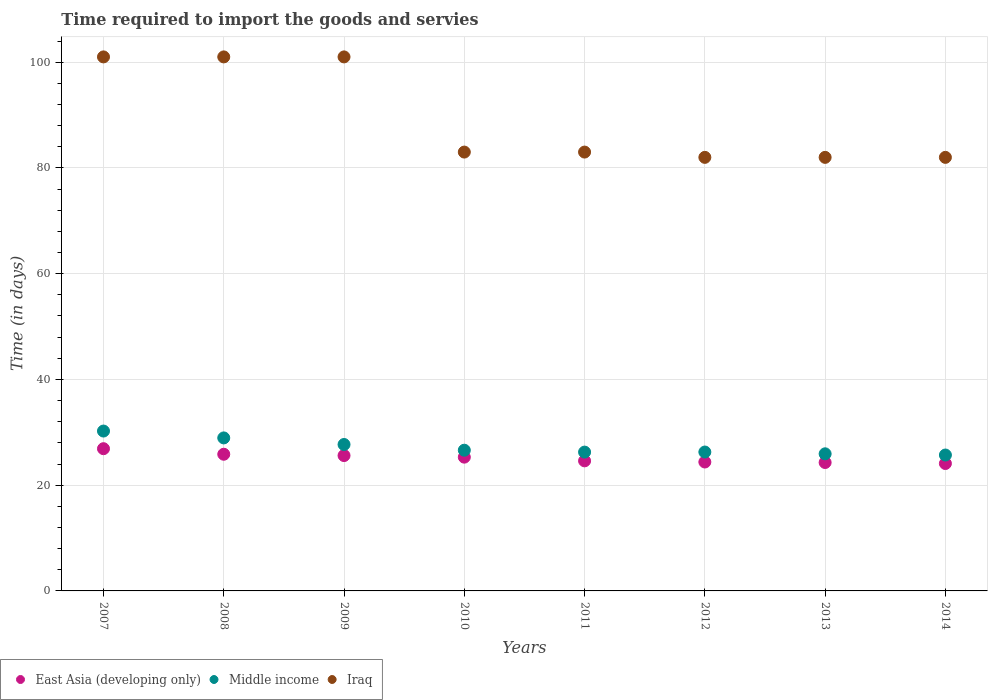How many different coloured dotlines are there?
Offer a terse response. 3. What is the number of days required to import the goods and services in East Asia (developing only) in 2010?
Offer a terse response. 25.3. Across all years, what is the maximum number of days required to import the goods and services in Iraq?
Keep it short and to the point. 101. Across all years, what is the minimum number of days required to import the goods and services in Middle income?
Give a very brief answer. 25.7. In which year was the number of days required to import the goods and services in Middle income minimum?
Ensure brevity in your answer.  2014. What is the total number of days required to import the goods and services in Iraq in the graph?
Make the answer very short. 715. What is the difference between the number of days required to import the goods and services in Middle income in 2008 and that in 2014?
Your answer should be very brief. 3.24. What is the difference between the number of days required to import the goods and services in Iraq in 2013 and the number of days required to import the goods and services in Middle income in 2008?
Offer a terse response. 53.06. What is the average number of days required to import the goods and services in Middle income per year?
Your response must be concise. 27.21. In the year 2013, what is the difference between the number of days required to import the goods and services in Iraq and number of days required to import the goods and services in Middle income?
Keep it short and to the point. 56.07. What is the ratio of the number of days required to import the goods and services in East Asia (developing only) in 2010 to that in 2014?
Your answer should be compact. 1.05. Is the number of days required to import the goods and services in Middle income in 2010 less than that in 2013?
Make the answer very short. No. What is the difference between the highest and the second highest number of days required to import the goods and services in Middle income?
Ensure brevity in your answer.  1.3. What is the difference between the highest and the lowest number of days required to import the goods and services in Iraq?
Your response must be concise. 19. In how many years, is the number of days required to import the goods and services in Middle income greater than the average number of days required to import the goods and services in Middle income taken over all years?
Your response must be concise. 3. Is the sum of the number of days required to import the goods and services in Iraq in 2007 and 2013 greater than the maximum number of days required to import the goods and services in East Asia (developing only) across all years?
Your answer should be very brief. Yes. Is it the case that in every year, the sum of the number of days required to import the goods and services in East Asia (developing only) and number of days required to import the goods and services in Middle income  is greater than the number of days required to import the goods and services in Iraq?
Provide a succinct answer. No. How many years are there in the graph?
Provide a succinct answer. 8. What is the difference between two consecutive major ticks on the Y-axis?
Offer a very short reply. 20. Where does the legend appear in the graph?
Make the answer very short. Bottom left. What is the title of the graph?
Give a very brief answer. Time required to import the goods and servies. Does "Mauritius" appear as one of the legend labels in the graph?
Your answer should be compact. No. What is the label or title of the X-axis?
Your answer should be very brief. Years. What is the label or title of the Y-axis?
Offer a terse response. Time (in days). What is the Time (in days) of East Asia (developing only) in 2007?
Offer a terse response. 26.9. What is the Time (in days) of Middle income in 2007?
Your answer should be compact. 30.24. What is the Time (in days) in Iraq in 2007?
Ensure brevity in your answer.  101. What is the Time (in days) of East Asia (developing only) in 2008?
Your answer should be compact. 25.85. What is the Time (in days) of Middle income in 2008?
Your answer should be very brief. 28.94. What is the Time (in days) of Iraq in 2008?
Keep it short and to the point. 101. What is the Time (in days) of East Asia (developing only) in 2009?
Give a very brief answer. 25.6. What is the Time (in days) of Middle income in 2009?
Offer a terse response. 27.69. What is the Time (in days) of Iraq in 2009?
Offer a terse response. 101. What is the Time (in days) of East Asia (developing only) in 2010?
Provide a succinct answer. 25.3. What is the Time (in days) in Middle income in 2010?
Your answer should be very brief. 26.61. What is the Time (in days) in Iraq in 2010?
Your response must be concise. 83. What is the Time (in days) of East Asia (developing only) in 2011?
Ensure brevity in your answer.  24.6. What is the Time (in days) of Middle income in 2011?
Your response must be concise. 26.26. What is the Time (in days) in East Asia (developing only) in 2012?
Give a very brief answer. 24.38. What is the Time (in days) of Middle income in 2012?
Your response must be concise. 26.27. What is the Time (in days) in Iraq in 2012?
Provide a short and direct response. 82. What is the Time (in days) in East Asia (developing only) in 2013?
Your answer should be compact. 24.29. What is the Time (in days) in Middle income in 2013?
Your answer should be very brief. 25.93. What is the Time (in days) of East Asia (developing only) in 2014?
Make the answer very short. 24.1. What is the Time (in days) of Middle income in 2014?
Keep it short and to the point. 25.7. Across all years, what is the maximum Time (in days) in East Asia (developing only)?
Your answer should be compact. 26.9. Across all years, what is the maximum Time (in days) in Middle income?
Ensure brevity in your answer.  30.24. Across all years, what is the maximum Time (in days) of Iraq?
Keep it short and to the point. 101. Across all years, what is the minimum Time (in days) of East Asia (developing only)?
Provide a short and direct response. 24.1. Across all years, what is the minimum Time (in days) in Middle income?
Your answer should be compact. 25.7. Across all years, what is the minimum Time (in days) in Iraq?
Offer a terse response. 82. What is the total Time (in days) in East Asia (developing only) in the graph?
Give a very brief answer. 201.01. What is the total Time (in days) in Middle income in the graph?
Offer a terse response. 217.64. What is the total Time (in days) in Iraq in the graph?
Provide a short and direct response. 715. What is the difference between the Time (in days) of Middle income in 2007 and that in 2008?
Provide a short and direct response. 1.3. What is the difference between the Time (in days) in Middle income in 2007 and that in 2009?
Make the answer very short. 2.54. What is the difference between the Time (in days) of East Asia (developing only) in 2007 and that in 2010?
Give a very brief answer. 1.6. What is the difference between the Time (in days) of Middle income in 2007 and that in 2010?
Keep it short and to the point. 3.62. What is the difference between the Time (in days) in Middle income in 2007 and that in 2011?
Ensure brevity in your answer.  3.98. What is the difference between the Time (in days) of East Asia (developing only) in 2007 and that in 2012?
Your answer should be very brief. 2.52. What is the difference between the Time (in days) of Middle income in 2007 and that in 2012?
Give a very brief answer. 3.97. What is the difference between the Time (in days) in East Asia (developing only) in 2007 and that in 2013?
Your answer should be very brief. 2.61. What is the difference between the Time (in days) in Middle income in 2007 and that in 2013?
Offer a terse response. 4.31. What is the difference between the Time (in days) in East Asia (developing only) in 2007 and that in 2014?
Provide a short and direct response. 2.8. What is the difference between the Time (in days) of Middle income in 2007 and that in 2014?
Your response must be concise. 4.54. What is the difference between the Time (in days) in Iraq in 2007 and that in 2014?
Offer a terse response. 19. What is the difference between the Time (in days) of East Asia (developing only) in 2008 and that in 2009?
Provide a short and direct response. 0.25. What is the difference between the Time (in days) in Middle income in 2008 and that in 2009?
Offer a very short reply. 1.24. What is the difference between the Time (in days) of Iraq in 2008 and that in 2009?
Keep it short and to the point. 0. What is the difference between the Time (in days) of East Asia (developing only) in 2008 and that in 2010?
Your response must be concise. 0.55. What is the difference between the Time (in days) of Middle income in 2008 and that in 2010?
Give a very brief answer. 2.33. What is the difference between the Time (in days) of Middle income in 2008 and that in 2011?
Your answer should be compact. 2.68. What is the difference between the Time (in days) of East Asia (developing only) in 2008 and that in 2012?
Provide a short and direct response. 1.47. What is the difference between the Time (in days) of Middle income in 2008 and that in 2012?
Offer a very short reply. 2.67. What is the difference between the Time (in days) in East Asia (developing only) in 2008 and that in 2013?
Give a very brief answer. 1.56. What is the difference between the Time (in days) in Middle income in 2008 and that in 2013?
Ensure brevity in your answer.  3.01. What is the difference between the Time (in days) in East Asia (developing only) in 2008 and that in 2014?
Keep it short and to the point. 1.75. What is the difference between the Time (in days) of Middle income in 2008 and that in 2014?
Keep it short and to the point. 3.24. What is the difference between the Time (in days) in Iraq in 2008 and that in 2014?
Ensure brevity in your answer.  19. What is the difference between the Time (in days) in East Asia (developing only) in 2009 and that in 2010?
Keep it short and to the point. 0.3. What is the difference between the Time (in days) of Middle income in 2009 and that in 2010?
Keep it short and to the point. 1.08. What is the difference between the Time (in days) in Iraq in 2009 and that in 2010?
Ensure brevity in your answer.  18. What is the difference between the Time (in days) of Middle income in 2009 and that in 2011?
Your answer should be compact. 1.44. What is the difference between the Time (in days) of Iraq in 2009 and that in 2011?
Offer a very short reply. 18. What is the difference between the Time (in days) in East Asia (developing only) in 2009 and that in 2012?
Provide a succinct answer. 1.22. What is the difference between the Time (in days) in Middle income in 2009 and that in 2012?
Your answer should be very brief. 1.42. What is the difference between the Time (in days) of Iraq in 2009 and that in 2012?
Ensure brevity in your answer.  19. What is the difference between the Time (in days) in East Asia (developing only) in 2009 and that in 2013?
Make the answer very short. 1.31. What is the difference between the Time (in days) in Middle income in 2009 and that in 2013?
Offer a very short reply. 1.76. What is the difference between the Time (in days) in East Asia (developing only) in 2009 and that in 2014?
Offer a terse response. 1.5. What is the difference between the Time (in days) of Middle income in 2009 and that in 2014?
Keep it short and to the point. 1.99. What is the difference between the Time (in days) in Middle income in 2010 and that in 2011?
Give a very brief answer. 0.36. What is the difference between the Time (in days) in Iraq in 2010 and that in 2011?
Make the answer very short. 0. What is the difference between the Time (in days) of East Asia (developing only) in 2010 and that in 2012?
Your answer should be very brief. 0.92. What is the difference between the Time (in days) in Middle income in 2010 and that in 2012?
Keep it short and to the point. 0.34. What is the difference between the Time (in days) in East Asia (developing only) in 2010 and that in 2013?
Make the answer very short. 1.01. What is the difference between the Time (in days) of Middle income in 2010 and that in 2013?
Provide a succinct answer. 0.68. What is the difference between the Time (in days) of Iraq in 2010 and that in 2013?
Offer a very short reply. 1. What is the difference between the Time (in days) in East Asia (developing only) in 2010 and that in 2014?
Offer a very short reply. 1.2. What is the difference between the Time (in days) in Middle income in 2010 and that in 2014?
Make the answer very short. 0.91. What is the difference between the Time (in days) of Iraq in 2010 and that in 2014?
Offer a very short reply. 1. What is the difference between the Time (in days) in East Asia (developing only) in 2011 and that in 2012?
Offer a very short reply. 0.22. What is the difference between the Time (in days) of Middle income in 2011 and that in 2012?
Give a very brief answer. -0.01. What is the difference between the Time (in days) of East Asia (developing only) in 2011 and that in 2013?
Provide a succinct answer. 0.31. What is the difference between the Time (in days) in Middle income in 2011 and that in 2013?
Your response must be concise. 0.32. What is the difference between the Time (in days) in East Asia (developing only) in 2011 and that in 2014?
Your answer should be compact. 0.5. What is the difference between the Time (in days) of Middle income in 2011 and that in 2014?
Ensure brevity in your answer.  0.55. What is the difference between the Time (in days) of Iraq in 2011 and that in 2014?
Provide a short and direct response. 1. What is the difference between the Time (in days) in East Asia (developing only) in 2012 and that in 2013?
Your answer should be compact. 0.1. What is the difference between the Time (in days) in Middle income in 2012 and that in 2013?
Your answer should be compact. 0.34. What is the difference between the Time (in days) in East Asia (developing only) in 2012 and that in 2014?
Your answer should be compact. 0.29. What is the difference between the Time (in days) of Middle income in 2012 and that in 2014?
Your answer should be compact. 0.57. What is the difference between the Time (in days) of East Asia (developing only) in 2013 and that in 2014?
Offer a very short reply. 0.19. What is the difference between the Time (in days) of Middle income in 2013 and that in 2014?
Your answer should be very brief. 0.23. What is the difference between the Time (in days) in East Asia (developing only) in 2007 and the Time (in days) in Middle income in 2008?
Offer a terse response. -2.04. What is the difference between the Time (in days) in East Asia (developing only) in 2007 and the Time (in days) in Iraq in 2008?
Offer a terse response. -74.1. What is the difference between the Time (in days) in Middle income in 2007 and the Time (in days) in Iraq in 2008?
Give a very brief answer. -70.76. What is the difference between the Time (in days) in East Asia (developing only) in 2007 and the Time (in days) in Middle income in 2009?
Ensure brevity in your answer.  -0.79. What is the difference between the Time (in days) of East Asia (developing only) in 2007 and the Time (in days) of Iraq in 2009?
Provide a succinct answer. -74.1. What is the difference between the Time (in days) in Middle income in 2007 and the Time (in days) in Iraq in 2009?
Offer a terse response. -70.76. What is the difference between the Time (in days) of East Asia (developing only) in 2007 and the Time (in days) of Middle income in 2010?
Keep it short and to the point. 0.29. What is the difference between the Time (in days) in East Asia (developing only) in 2007 and the Time (in days) in Iraq in 2010?
Offer a terse response. -56.1. What is the difference between the Time (in days) in Middle income in 2007 and the Time (in days) in Iraq in 2010?
Your answer should be compact. -52.76. What is the difference between the Time (in days) in East Asia (developing only) in 2007 and the Time (in days) in Middle income in 2011?
Your answer should be very brief. 0.64. What is the difference between the Time (in days) of East Asia (developing only) in 2007 and the Time (in days) of Iraq in 2011?
Ensure brevity in your answer.  -56.1. What is the difference between the Time (in days) of Middle income in 2007 and the Time (in days) of Iraq in 2011?
Your response must be concise. -52.76. What is the difference between the Time (in days) of East Asia (developing only) in 2007 and the Time (in days) of Middle income in 2012?
Your answer should be very brief. 0.63. What is the difference between the Time (in days) in East Asia (developing only) in 2007 and the Time (in days) in Iraq in 2012?
Your answer should be very brief. -55.1. What is the difference between the Time (in days) in Middle income in 2007 and the Time (in days) in Iraq in 2012?
Offer a very short reply. -51.76. What is the difference between the Time (in days) of East Asia (developing only) in 2007 and the Time (in days) of Iraq in 2013?
Keep it short and to the point. -55.1. What is the difference between the Time (in days) of Middle income in 2007 and the Time (in days) of Iraq in 2013?
Keep it short and to the point. -51.76. What is the difference between the Time (in days) of East Asia (developing only) in 2007 and the Time (in days) of Middle income in 2014?
Offer a terse response. 1.2. What is the difference between the Time (in days) of East Asia (developing only) in 2007 and the Time (in days) of Iraq in 2014?
Make the answer very short. -55.1. What is the difference between the Time (in days) in Middle income in 2007 and the Time (in days) in Iraq in 2014?
Your answer should be compact. -51.76. What is the difference between the Time (in days) of East Asia (developing only) in 2008 and the Time (in days) of Middle income in 2009?
Give a very brief answer. -1.84. What is the difference between the Time (in days) in East Asia (developing only) in 2008 and the Time (in days) in Iraq in 2009?
Provide a short and direct response. -75.15. What is the difference between the Time (in days) in Middle income in 2008 and the Time (in days) in Iraq in 2009?
Give a very brief answer. -72.06. What is the difference between the Time (in days) of East Asia (developing only) in 2008 and the Time (in days) of Middle income in 2010?
Make the answer very short. -0.76. What is the difference between the Time (in days) of East Asia (developing only) in 2008 and the Time (in days) of Iraq in 2010?
Offer a terse response. -57.15. What is the difference between the Time (in days) in Middle income in 2008 and the Time (in days) in Iraq in 2010?
Provide a short and direct response. -54.06. What is the difference between the Time (in days) in East Asia (developing only) in 2008 and the Time (in days) in Middle income in 2011?
Provide a succinct answer. -0.41. What is the difference between the Time (in days) in East Asia (developing only) in 2008 and the Time (in days) in Iraq in 2011?
Provide a short and direct response. -57.15. What is the difference between the Time (in days) of Middle income in 2008 and the Time (in days) of Iraq in 2011?
Give a very brief answer. -54.06. What is the difference between the Time (in days) of East Asia (developing only) in 2008 and the Time (in days) of Middle income in 2012?
Give a very brief answer. -0.42. What is the difference between the Time (in days) in East Asia (developing only) in 2008 and the Time (in days) in Iraq in 2012?
Keep it short and to the point. -56.15. What is the difference between the Time (in days) of Middle income in 2008 and the Time (in days) of Iraq in 2012?
Your response must be concise. -53.06. What is the difference between the Time (in days) in East Asia (developing only) in 2008 and the Time (in days) in Middle income in 2013?
Give a very brief answer. -0.08. What is the difference between the Time (in days) of East Asia (developing only) in 2008 and the Time (in days) of Iraq in 2013?
Offer a very short reply. -56.15. What is the difference between the Time (in days) of Middle income in 2008 and the Time (in days) of Iraq in 2013?
Provide a succinct answer. -53.06. What is the difference between the Time (in days) in East Asia (developing only) in 2008 and the Time (in days) in Middle income in 2014?
Offer a terse response. 0.15. What is the difference between the Time (in days) in East Asia (developing only) in 2008 and the Time (in days) in Iraq in 2014?
Keep it short and to the point. -56.15. What is the difference between the Time (in days) in Middle income in 2008 and the Time (in days) in Iraq in 2014?
Keep it short and to the point. -53.06. What is the difference between the Time (in days) of East Asia (developing only) in 2009 and the Time (in days) of Middle income in 2010?
Offer a terse response. -1.01. What is the difference between the Time (in days) in East Asia (developing only) in 2009 and the Time (in days) in Iraq in 2010?
Provide a short and direct response. -57.4. What is the difference between the Time (in days) in Middle income in 2009 and the Time (in days) in Iraq in 2010?
Offer a terse response. -55.31. What is the difference between the Time (in days) of East Asia (developing only) in 2009 and the Time (in days) of Middle income in 2011?
Provide a short and direct response. -0.66. What is the difference between the Time (in days) of East Asia (developing only) in 2009 and the Time (in days) of Iraq in 2011?
Give a very brief answer. -57.4. What is the difference between the Time (in days) in Middle income in 2009 and the Time (in days) in Iraq in 2011?
Your answer should be very brief. -55.31. What is the difference between the Time (in days) of East Asia (developing only) in 2009 and the Time (in days) of Middle income in 2012?
Your answer should be compact. -0.67. What is the difference between the Time (in days) of East Asia (developing only) in 2009 and the Time (in days) of Iraq in 2012?
Ensure brevity in your answer.  -56.4. What is the difference between the Time (in days) in Middle income in 2009 and the Time (in days) in Iraq in 2012?
Your response must be concise. -54.31. What is the difference between the Time (in days) of East Asia (developing only) in 2009 and the Time (in days) of Middle income in 2013?
Your response must be concise. -0.33. What is the difference between the Time (in days) of East Asia (developing only) in 2009 and the Time (in days) of Iraq in 2013?
Your answer should be compact. -56.4. What is the difference between the Time (in days) in Middle income in 2009 and the Time (in days) in Iraq in 2013?
Your answer should be compact. -54.31. What is the difference between the Time (in days) of East Asia (developing only) in 2009 and the Time (in days) of Middle income in 2014?
Offer a terse response. -0.1. What is the difference between the Time (in days) in East Asia (developing only) in 2009 and the Time (in days) in Iraq in 2014?
Keep it short and to the point. -56.4. What is the difference between the Time (in days) of Middle income in 2009 and the Time (in days) of Iraq in 2014?
Provide a succinct answer. -54.31. What is the difference between the Time (in days) in East Asia (developing only) in 2010 and the Time (in days) in Middle income in 2011?
Your response must be concise. -0.96. What is the difference between the Time (in days) of East Asia (developing only) in 2010 and the Time (in days) of Iraq in 2011?
Your answer should be very brief. -57.7. What is the difference between the Time (in days) in Middle income in 2010 and the Time (in days) in Iraq in 2011?
Make the answer very short. -56.39. What is the difference between the Time (in days) of East Asia (developing only) in 2010 and the Time (in days) of Middle income in 2012?
Make the answer very short. -0.97. What is the difference between the Time (in days) of East Asia (developing only) in 2010 and the Time (in days) of Iraq in 2012?
Make the answer very short. -56.7. What is the difference between the Time (in days) of Middle income in 2010 and the Time (in days) of Iraq in 2012?
Ensure brevity in your answer.  -55.39. What is the difference between the Time (in days) of East Asia (developing only) in 2010 and the Time (in days) of Middle income in 2013?
Provide a short and direct response. -0.63. What is the difference between the Time (in days) of East Asia (developing only) in 2010 and the Time (in days) of Iraq in 2013?
Give a very brief answer. -56.7. What is the difference between the Time (in days) of Middle income in 2010 and the Time (in days) of Iraq in 2013?
Keep it short and to the point. -55.39. What is the difference between the Time (in days) in East Asia (developing only) in 2010 and the Time (in days) in Middle income in 2014?
Your response must be concise. -0.4. What is the difference between the Time (in days) of East Asia (developing only) in 2010 and the Time (in days) of Iraq in 2014?
Keep it short and to the point. -56.7. What is the difference between the Time (in days) of Middle income in 2010 and the Time (in days) of Iraq in 2014?
Your answer should be compact. -55.39. What is the difference between the Time (in days) in East Asia (developing only) in 2011 and the Time (in days) in Middle income in 2012?
Make the answer very short. -1.67. What is the difference between the Time (in days) of East Asia (developing only) in 2011 and the Time (in days) of Iraq in 2012?
Offer a terse response. -57.4. What is the difference between the Time (in days) in Middle income in 2011 and the Time (in days) in Iraq in 2012?
Your answer should be compact. -55.74. What is the difference between the Time (in days) of East Asia (developing only) in 2011 and the Time (in days) of Middle income in 2013?
Provide a short and direct response. -1.33. What is the difference between the Time (in days) in East Asia (developing only) in 2011 and the Time (in days) in Iraq in 2013?
Provide a succinct answer. -57.4. What is the difference between the Time (in days) in Middle income in 2011 and the Time (in days) in Iraq in 2013?
Your answer should be very brief. -55.74. What is the difference between the Time (in days) of East Asia (developing only) in 2011 and the Time (in days) of Middle income in 2014?
Make the answer very short. -1.1. What is the difference between the Time (in days) in East Asia (developing only) in 2011 and the Time (in days) in Iraq in 2014?
Provide a short and direct response. -57.4. What is the difference between the Time (in days) of Middle income in 2011 and the Time (in days) of Iraq in 2014?
Give a very brief answer. -55.74. What is the difference between the Time (in days) in East Asia (developing only) in 2012 and the Time (in days) in Middle income in 2013?
Give a very brief answer. -1.55. What is the difference between the Time (in days) in East Asia (developing only) in 2012 and the Time (in days) in Iraq in 2013?
Your response must be concise. -57.62. What is the difference between the Time (in days) of Middle income in 2012 and the Time (in days) of Iraq in 2013?
Your answer should be very brief. -55.73. What is the difference between the Time (in days) of East Asia (developing only) in 2012 and the Time (in days) of Middle income in 2014?
Provide a succinct answer. -1.32. What is the difference between the Time (in days) of East Asia (developing only) in 2012 and the Time (in days) of Iraq in 2014?
Your response must be concise. -57.62. What is the difference between the Time (in days) in Middle income in 2012 and the Time (in days) in Iraq in 2014?
Your answer should be very brief. -55.73. What is the difference between the Time (in days) of East Asia (developing only) in 2013 and the Time (in days) of Middle income in 2014?
Ensure brevity in your answer.  -1.42. What is the difference between the Time (in days) in East Asia (developing only) in 2013 and the Time (in days) in Iraq in 2014?
Your response must be concise. -57.71. What is the difference between the Time (in days) in Middle income in 2013 and the Time (in days) in Iraq in 2014?
Give a very brief answer. -56.07. What is the average Time (in days) in East Asia (developing only) per year?
Offer a very short reply. 25.13. What is the average Time (in days) in Middle income per year?
Provide a short and direct response. 27.21. What is the average Time (in days) of Iraq per year?
Your response must be concise. 89.38. In the year 2007, what is the difference between the Time (in days) in East Asia (developing only) and Time (in days) in Middle income?
Offer a terse response. -3.34. In the year 2007, what is the difference between the Time (in days) in East Asia (developing only) and Time (in days) in Iraq?
Offer a terse response. -74.1. In the year 2007, what is the difference between the Time (in days) in Middle income and Time (in days) in Iraq?
Offer a very short reply. -70.76. In the year 2008, what is the difference between the Time (in days) of East Asia (developing only) and Time (in days) of Middle income?
Your answer should be compact. -3.09. In the year 2008, what is the difference between the Time (in days) of East Asia (developing only) and Time (in days) of Iraq?
Provide a succinct answer. -75.15. In the year 2008, what is the difference between the Time (in days) of Middle income and Time (in days) of Iraq?
Offer a very short reply. -72.06. In the year 2009, what is the difference between the Time (in days) in East Asia (developing only) and Time (in days) in Middle income?
Your answer should be very brief. -2.09. In the year 2009, what is the difference between the Time (in days) of East Asia (developing only) and Time (in days) of Iraq?
Make the answer very short. -75.4. In the year 2009, what is the difference between the Time (in days) of Middle income and Time (in days) of Iraq?
Provide a short and direct response. -73.31. In the year 2010, what is the difference between the Time (in days) of East Asia (developing only) and Time (in days) of Middle income?
Your response must be concise. -1.31. In the year 2010, what is the difference between the Time (in days) in East Asia (developing only) and Time (in days) in Iraq?
Your response must be concise. -57.7. In the year 2010, what is the difference between the Time (in days) in Middle income and Time (in days) in Iraq?
Offer a very short reply. -56.39. In the year 2011, what is the difference between the Time (in days) in East Asia (developing only) and Time (in days) in Middle income?
Your answer should be compact. -1.66. In the year 2011, what is the difference between the Time (in days) in East Asia (developing only) and Time (in days) in Iraq?
Your answer should be very brief. -58.4. In the year 2011, what is the difference between the Time (in days) of Middle income and Time (in days) of Iraq?
Make the answer very short. -56.74. In the year 2012, what is the difference between the Time (in days) of East Asia (developing only) and Time (in days) of Middle income?
Ensure brevity in your answer.  -1.89. In the year 2012, what is the difference between the Time (in days) of East Asia (developing only) and Time (in days) of Iraq?
Offer a terse response. -57.62. In the year 2012, what is the difference between the Time (in days) of Middle income and Time (in days) of Iraq?
Offer a terse response. -55.73. In the year 2013, what is the difference between the Time (in days) of East Asia (developing only) and Time (in days) of Middle income?
Offer a very short reply. -1.65. In the year 2013, what is the difference between the Time (in days) of East Asia (developing only) and Time (in days) of Iraq?
Keep it short and to the point. -57.71. In the year 2013, what is the difference between the Time (in days) of Middle income and Time (in days) of Iraq?
Ensure brevity in your answer.  -56.07. In the year 2014, what is the difference between the Time (in days) of East Asia (developing only) and Time (in days) of Middle income?
Provide a short and direct response. -1.61. In the year 2014, what is the difference between the Time (in days) of East Asia (developing only) and Time (in days) of Iraq?
Ensure brevity in your answer.  -57.9. In the year 2014, what is the difference between the Time (in days) in Middle income and Time (in days) in Iraq?
Ensure brevity in your answer.  -56.3. What is the ratio of the Time (in days) of East Asia (developing only) in 2007 to that in 2008?
Your answer should be compact. 1.04. What is the ratio of the Time (in days) in Middle income in 2007 to that in 2008?
Your response must be concise. 1.04. What is the ratio of the Time (in days) of Iraq in 2007 to that in 2008?
Your answer should be very brief. 1. What is the ratio of the Time (in days) in East Asia (developing only) in 2007 to that in 2009?
Provide a succinct answer. 1.05. What is the ratio of the Time (in days) in Middle income in 2007 to that in 2009?
Your response must be concise. 1.09. What is the ratio of the Time (in days) in East Asia (developing only) in 2007 to that in 2010?
Offer a very short reply. 1.06. What is the ratio of the Time (in days) of Middle income in 2007 to that in 2010?
Offer a terse response. 1.14. What is the ratio of the Time (in days) in Iraq in 2007 to that in 2010?
Keep it short and to the point. 1.22. What is the ratio of the Time (in days) of East Asia (developing only) in 2007 to that in 2011?
Your response must be concise. 1.09. What is the ratio of the Time (in days) in Middle income in 2007 to that in 2011?
Make the answer very short. 1.15. What is the ratio of the Time (in days) in Iraq in 2007 to that in 2011?
Keep it short and to the point. 1.22. What is the ratio of the Time (in days) in East Asia (developing only) in 2007 to that in 2012?
Offer a very short reply. 1.1. What is the ratio of the Time (in days) in Middle income in 2007 to that in 2012?
Give a very brief answer. 1.15. What is the ratio of the Time (in days) in Iraq in 2007 to that in 2012?
Ensure brevity in your answer.  1.23. What is the ratio of the Time (in days) of East Asia (developing only) in 2007 to that in 2013?
Provide a short and direct response. 1.11. What is the ratio of the Time (in days) in Middle income in 2007 to that in 2013?
Ensure brevity in your answer.  1.17. What is the ratio of the Time (in days) in Iraq in 2007 to that in 2013?
Your answer should be very brief. 1.23. What is the ratio of the Time (in days) in East Asia (developing only) in 2007 to that in 2014?
Your response must be concise. 1.12. What is the ratio of the Time (in days) of Middle income in 2007 to that in 2014?
Your response must be concise. 1.18. What is the ratio of the Time (in days) of Iraq in 2007 to that in 2014?
Your answer should be compact. 1.23. What is the ratio of the Time (in days) of East Asia (developing only) in 2008 to that in 2009?
Your response must be concise. 1.01. What is the ratio of the Time (in days) of Middle income in 2008 to that in 2009?
Offer a terse response. 1.04. What is the ratio of the Time (in days) of Iraq in 2008 to that in 2009?
Ensure brevity in your answer.  1. What is the ratio of the Time (in days) of East Asia (developing only) in 2008 to that in 2010?
Ensure brevity in your answer.  1.02. What is the ratio of the Time (in days) of Middle income in 2008 to that in 2010?
Make the answer very short. 1.09. What is the ratio of the Time (in days) of Iraq in 2008 to that in 2010?
Give a very brief answer. 1.22. What is the ratio of the Time (in days) in East Asia (developing only) in 2008 to that in 2011?
Give a very brief answer. 1.05. What is the ratio of the Time (in days) in Middle income in 2008 to that in 2011?
Ensure brevity in your answer.  1.1. What is the ratio of the Time (in days) of Iraq in 2008 to that in 2011?
Ensure brevity in your answer.  1.22. What is the ratio of the Time (in days) in East Asia (developing only) in 2008 to that in 2012?
Provide a succinct answer. 1.06. What is the ratio of the Time (in days) of Middle income in 2008 to that in 2012?
Provide a short and direct response. 1.1. What is the ratio of the Time (in days) in Iraq in 2008 to that in 2012?
Your answer should be very brief. 1.23. What is the ratio of the Time (in days) of East Asia (developing only) in 2008 to that in 2013?
Ensure brevity in your answer.  1.06. What is the ratio of the Time (in days) of Middle income in 2008 to that in 2013?
Your answer should be very brief. 1.12. What is the ratio of the Time (in days) of Iraq in 2008 to that in 2013?
Keep it short and to the point. 1.23. What is the ratio of the Time (in days) in East Asia (developing only) in 2008 to that in 2014?
Your answer should be compact. 1.07. What is the ratio of the Time (in days) in Middle income in 2008 to that in 2014?
Offer a very short reply. 1.13. What is the ratio of the Time (in days) in Iraq in 2008 to that in 2014?
Offer a terse response. 1.23. What is the ratio of the Time (in days) in East Asia (developing only) in 2009 to that in 2010?
Offer a terse response. 1.01. What is the ratio of the Time (in days) in Middle income in 2009 to that in 2010?
Give a very brief answer. 1.04. What is the ratio of the Time (in days) of Iraq in 2009 to that in 2010?
Your answer should be compact. 1.22. What is the ratio of the Time (in days) in East Asia (developing only) in 2009 to that in 2011?
Give a very brief answer. 1.04. What is the ratio of the Time (in days) of Middle income in 2009 to that in 2011?
Provide a succinct answer. 1.05. What is the ratio of the Time (in days) of Iraq in 2009 to that in 2011?
Keep it short and to the point. 1.22. What is the ratio of the Time (in days) of Middle income in 2009 to that in 2012?
Keep it short and to the point. 1.05. What is the ratio of the Time (in days) of Iraq in 2009 to that in 2012?
Give a very brief answer. 1.23. What is the ratio of the Time (in days) of East Asia (developing only) in 2009 to that in 2013?
Your response must be concise. 1.05. What is the ratio of the Time (in days) in Middle income in 2009 to that in 2013?
Your answer should be very brief. 1.07. What is the ratio of the Time (in days) of Iraq in 2009 to that in 2013?
Ensure brevity in your answer.  1.23. What is the ratio of the Time (in days) in East Asia (developing only) in 2009 to that in 2014?
Provide a succinct answer. 1.06. What is the ratio of the Time (in days) in Middle income in 2009 to that in 2014?
Offer a terse response. 1.08. What is the ratio of the Time (in days) of Iraq in 2009 to that in 2014?
Provide a succinct answer. 1.23. What is the ratio of the Time (in days) of East Asia (developing only) in 2010 to that in 2011?
Your response must be concise. 1.03. What is the ratio of the Time (in days) of Middle income in 2010 to that in 2011?
Give a very brief answer. 1.01. What is the ratio of the Time (in days) in East Asia (developing only) in 2010 to that in 2012?
Give a very brief answer. 1.04. What is the ratio of the Time (in days) of Iraq in 2010 to that in 2012?
Your response must be concise. 1.01. What is the ratio of the Time (in days) of East Asia (developing only) in 2010 to that in 2013?
Provide a succinct answer. 1.04. What is the ratio of the Time (in days) in Middle income in 2010 to that in 2013?
Your answer should be compact. 1.03. What is the ratio of the Time (in days) in Iraq in 2010 to that in 2013?
Your answer should be very brief. 1.01. What is the ratio of the Time (in days) in East Asia (developing only) in 2010 to that in 2014?
Offer a very short reply. 1.05. What is the ratio of the Time (in days) of Middle income in 2010 to that in 2014?
Make the answer very short. 1.04. What is the ratio of the Time (in days) of Iraq in 2010 to that in 2014?
Your answer should be very brief. 1.01. What is the ratio of the Time (in days) in East Asia (developing only) in 2011 to that in 2012?
Ensure brevity in your answer.  1.01. What is the ratio of the Time (in days) in Middle income in 2011 to that in 2012?
Your response must be concise. 1. What is the ratio of the Time (in days) in Iraq in 2011 to that in 2012?
Ensure brevity in your answer.  1.01. What is the ratio of the Time (in days) in East Asia (developing only) in 2011 to that in 2013?
Make the answer very short. 1.01. What is the ratio of the Time (in days) of Middle income in 2011 to that in 2013?
Offer a very short reply. 1.01. What is the ratio of the Time (in days) in Iraq in 2011 to that in 2013?
Provide a succinct answer. 1.01. What is the ratio of the Time (in days) of East Asia (developing only) in 2011 to that in 2014?
Your response must be concise. 1.02. What is the ratio of the Time (in days) in Middle income in 2011 to that in 2014?
Your answer should be very brief. 1.02. What is the ratio of the Time (in days) in Iraq in 2011 to that in 2014?
Provide a succinct answer. 1.01. What is the ratio of the Time (in days) of East Asia (developing only) in 2012 to that in 2013?
Offer a very short reply. 1. What is the ratio of the Time (in days) of Iraq in 2012 to that in 2013?
Keep it short and to the point. 1. What is the ratio of the Time (in days) of East Asia (developing only) in 2012 to that in 2014?
Offer a very short reply. 1.01. What is the ratio of the Time (in days) of Middle income in 2012 to that in 2014?
Provide a short and direct response. 1.02. What is the ratio of the Time (in days) in Iraq in 2012 to that in 2014?
Give a very brief answer. 1. What is the ratio of the Time (in days) of East Asia (developing only) in 2013 to that in 2014?
Your response must be concise. 1.01. What is the ratio of the Time (in days) of Middle income in 2013 to that in 2014?
Your answer should be very brief. 1.01. What is the ratio of the Time (in days) of Iraq in 2013 to that in 2014?
Offer a very short reply. 1. What is the difference between the highest and the second highest Time (in days) in East Asia (developing only)?
Make the answer very short. 1.05. What is the difference between the highest and the second highest Time (in days) of Middle income?
Ensure brevity in your answer.  1.3. What is the difference between the highest and the lowest Time (in days) of East Asia (developing only)?
Give a very brief answer. 2.8. What is the difference between the highest and the lowest Time (in days) of Middle income?
Your answer should be very brief. 4.54. 